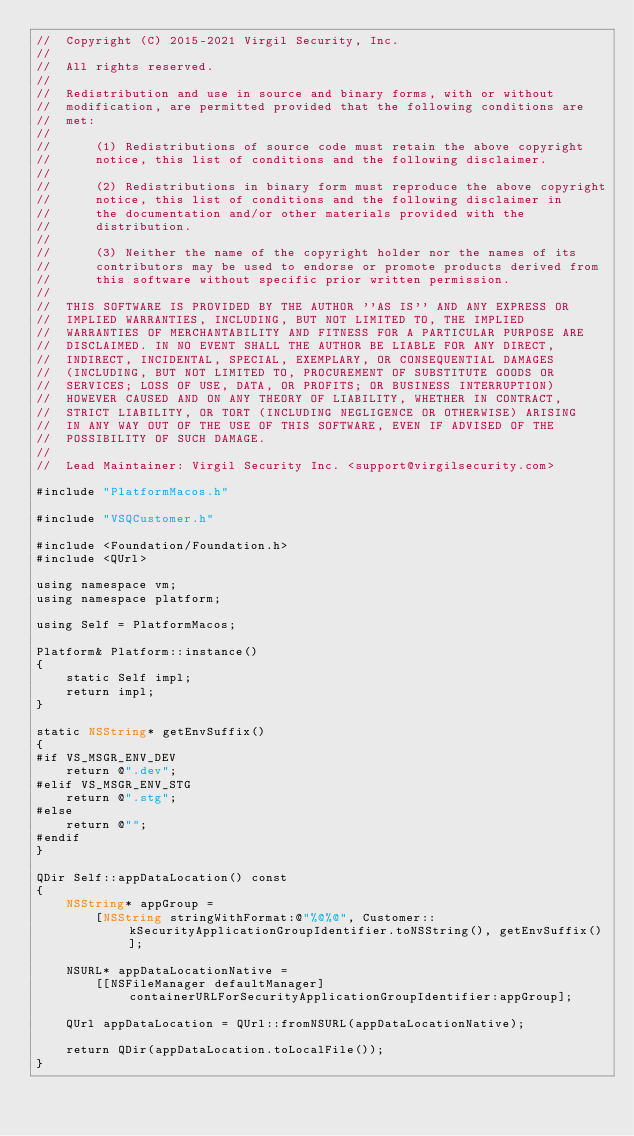<code> <loc_0><loc_0><loc_500><loc_500><_ObjectiveC_>//  Copyright (C) 2015-2021 Virgil Security, Inc.
//
//  All rights reserved.
//
//  Redistribution and use in source and binary forms, with or without
//  modification, are permitted provided that the following conditions are
//  met:
//
//      (1) Redistributions of source code must retain the above copyright
//      notice, this list of conditions and the following disclaimer.
//
//      (2) Redistributions in binary form must reproduce the above copyright
//      notice, this list of conditions and the following disclaimer in
//      the documentation and/or other materials provided with the
//      distribution.
//
//      (3) Neither the name of the copyright holder nor the names of its
//      contributors may be used to endorse or promote products derived from
//      this software without specific prior written permission.
//
//  THIS SOFTWARE IS PROVIDED BY THE AUTHOR ''AS IS'' AND ANY EXPRESS OR
//  IMPLIED WARRANTIES, INCLUDING, BUT NOT LIMITED TO, THE IMPLIED
//  WARRANTIES OF MERCHANTABILITY AND FITNESS FOR A PARTICULAR PURPOSE ARE
//  DISCLAIMED. IN NO EVENT SHALL THE AUTHOR BE LIABLE FOR ANY DIRECT,
//  INDIRECT, INCIDENTAL, SPECIAL, EXEMPLARY, OR CONSEQUENTIAL DAMAGES
//  (INCLUDING, BUT NOT LIMITED TO, PROCUREMENT OF SUBSTITUTE GOODS OR
//  SERVICES; LOSS OF USE, DATA, OR PROFITS; OR BUSINESS INTERRUPTION)
//  HOWEVER CAUSED AND ON ANY THEORY OF LIABILITY, WHETHER IN CONTRACT,
//  STRICT LIABILITY, OR TORT (INCLUDING NEGLIGENCE OR OTHERWISE) ARISING
//  IN ANY WAY OUT OF THE USE OF THIS SOFTWARE, EVEN IF ADVISED OF THE
//  POSSIBILITY OF SUCH DAMAGE.
//
//  Lead Maintainer: Virgil Security Inc. <support@virgilsecurity.com>

#include "PlatformMacos.h"

#include "VSQCustomer.h"

#include <Foundation/Foundation.h>
#include <QUrl>

using namespace vm;
using namespace platform;

using Self = PlatformMacos;

Platform& Platform::instance()
{
    static Self impl;
    return impl;
}

static NSString* getEnvSuffix()
{
#if VS_MSGR_ENV_DEV
    return @".dev";
#elif VS_MSGR_ENV_STG
    return @".stg";
#else
    return @"";
#endif
}

QDir Self::appDataLocation() const
{
    NSString* appGroup =
        [NSString stringWithFormat:@"%@%@", Customer::kSecurityApplicationGroupIdentifier.toNSString(), getEnvSuffix()];

    NSURL* appDataLocationNative =
        [[NSFileManager defaultManager] containerURLForSecurityApplicationGroupIdentifier:appGroup];

    QUrl appDataLocation = QUrl::fromNSURL(appDataLocationNative);

    return QDir(appDataLocation.toLocalFile());
}
</code> 